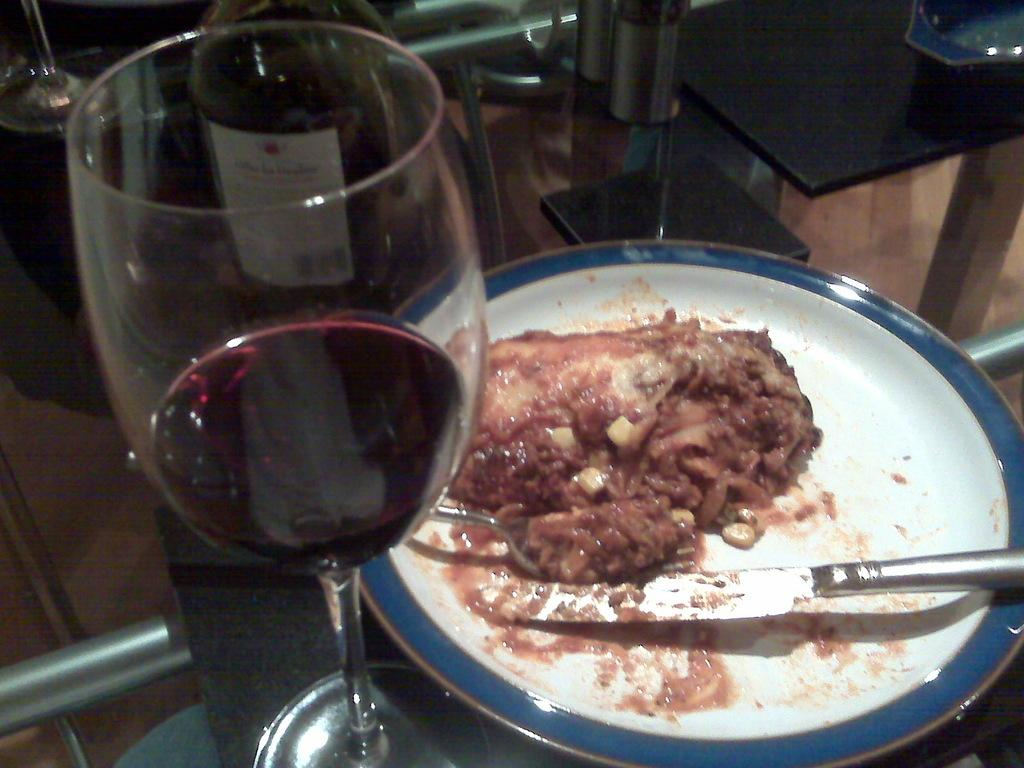What type of glass can be seen in the image? There is a wine glass in the image. What is on the plate in the image? There is a plate with food in the image. What utensils are present in the image? There is a fork and a knife in the image. What other type of glass is visible in the image? There is another glass in the image. What is the surface on which the glasses and plate are placed? There are other objects on a glass table in the image. Is there any blood visible on the plate or utensils in the image? No, there is no blood visible on the plate or utensils in the image. Can you tell me if the person who prepared the food is an aunt or an achiever? There is no information about the person who prepared the food or their relationship or achievements in the image. 